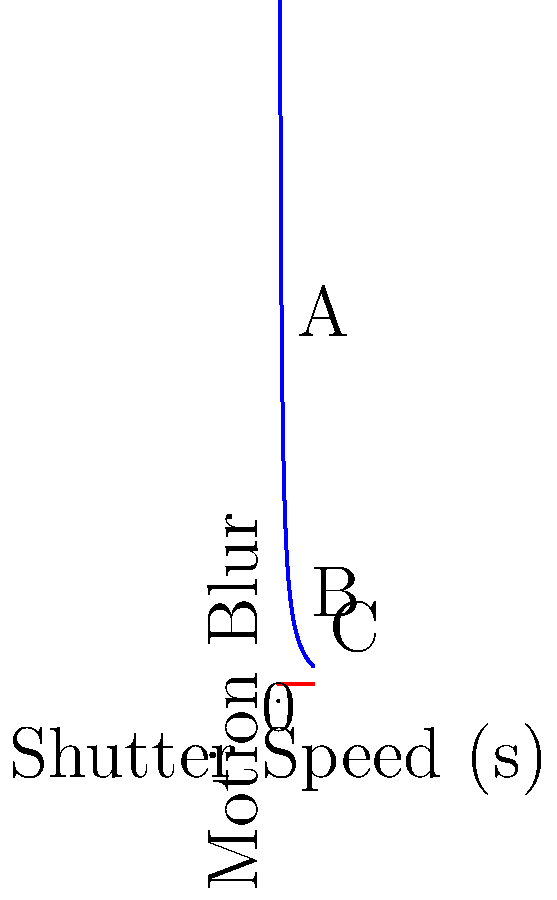As an Olympus enthusiast preparing for the new camera release, you're studying the relationship between shutter speed and motion blur. The graph shows motion blur as a function of shutter speed for a moving subject. If the subject's speed remains constant (red line), how does the motion blur change as the shutter speed increases from point A to C? Let's analyze this step-by-step:

1. The blue curve represents the relationship between shutter speed and motion blur.
2. The red line represents a constant subject speed.
3. Points A, B, and C correspond to increasing shutter speeds.

4. At point A (shortest shutter speed):
   - The motion blur is highest (y-axis value is largest).
   - This is because a fast-moving subject covers more distance relative to the short exposure time.

5. Moving from A to B:
   - As shutter speed increases, motion blur decreases.
   - This is shown by the downward slope of the blue curve.

6. At point C (longest shutter speed):
   - The motion blur is lowest (y-axis value is smallest).
   - With a longer exposure, the subject's movement is spread over a longer time, reducing perceived blur.

7. The relationship follows an inverse function: Motion Blur ≈ $\frac{1}{\text{Shutter Speed}}$

8. As shutter speed increases, the denominator of this fraction gets larger, resulting in a smaller overall value for motion blur.

Therefore, as the shutter speed increases from A to C, the motion blur decreases.
Answer: Decreases 